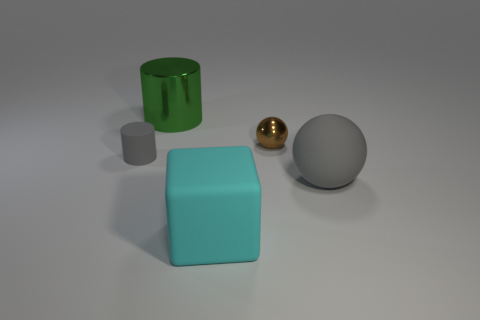Is the color of the rubber cylinder the same as the big ball?
Provide a short and direct response. Yes. Is the number of tiny gray cylinders greater than the number of gray rubber objects?
Ensure brevity in your answer.  No. How many large yellow cylinders are there?
Your answer should be compact. 0. There is a gray rubber thing that is on the left side of the big thing behind the ball that is in front of the small gray matte cylinder; what is its shape?
Provide a succinct answer. Cylinder. Is the number of small brown balls behind the large metallic object less than the number of large cyan rubber objects that are behind the large cyan matte cube?
Your response must be concise. No. Does the matte thing on the right side of the large cube have the same shape as the metal thing that is on the right side of the large cyan cube?
Your answer should be very brief. Yes. The gray matte object that is left of the large matte thing on the left side of the matte sphere is what shape?
Offer a very short reply. Cylinder. What size is the sphere that is the same color as the tiny matte cylinder?
Your answer should be very brief. Large. Are there any tiny blue balls made of the same material as the large cyan block?
Provide a succinct answer. No. What is the material of the large thing that is behind the large gray ball?
Offer a terse response. Metal. 